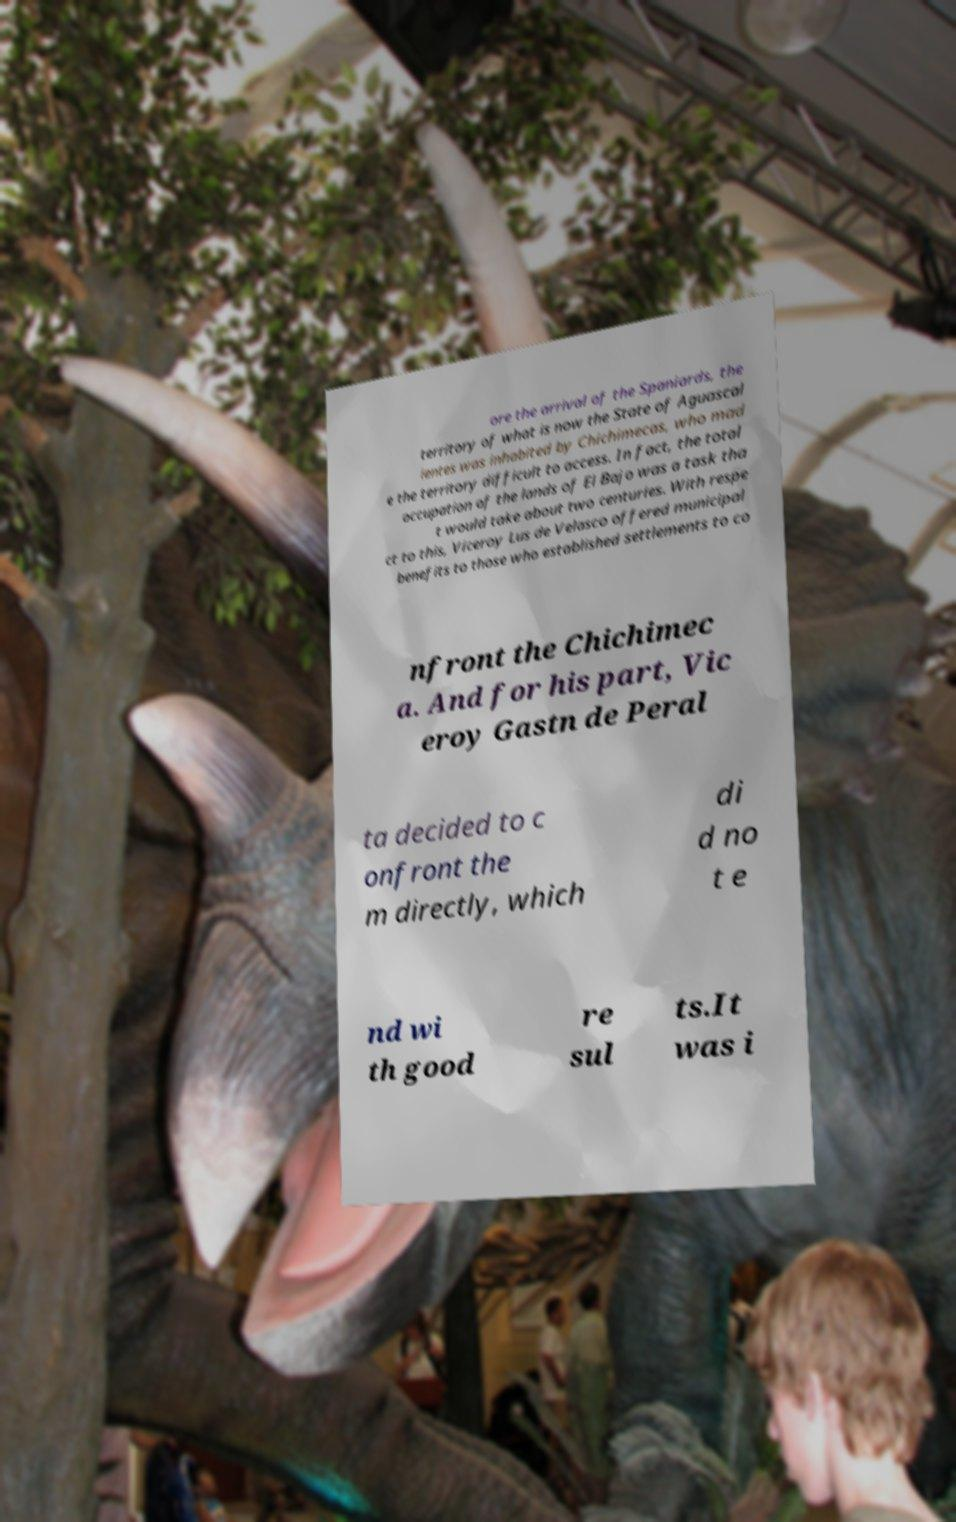Please read and relay the text visible in this image. What does it say? ore the arrival of the Spaniards, the territory of what is now the State of Aguascal ientes was inhabited by Chichimecas, who mad e the territory difficult to access. In fact, the total occupation of the lands of El Bajo was a task tha t would take about two centuries. With respe ct to this, Viceroy Lus de Velasco offered municipal benefits to those who established settlements to co nfront the Chichimec a. And for his part, Vic eroy Gastn de Peral ta decided to c onfront the m directly, which di d no t e nd wi th good re sul ts.It was i 